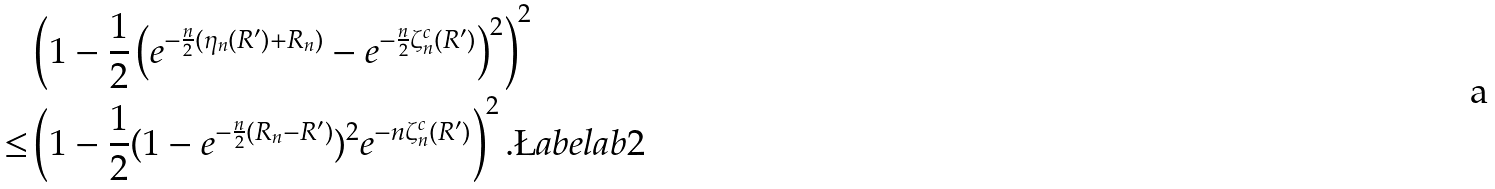Convert formula to latex. <formula><loc_0><loc_0><loc_500><loc_500>& \left ( 1 - \frac { 1 } { 2 } \left ( e ^ { - \frac { n } { 2 } ( \eta _ { n } ( R ^ { \prime } ) + R _ { n } ) } - e ^ { - \frac { n } { 2 } \zeta ^ { c } _ { n } ( R ^ { \prime } ) } \right ) ^ { 2 } \right ) ^ { 2 } \\ \leq & \left ( 1 - \frac { 1 } { 2 } ( 1 - e ^ { - \frac { n } { 2 } ( R _ { n } - R ^ { \prime } ) } ) ^ { 2 } e ^ { - n \zeta ^ { c } _ { n } ( R ^ { \prime } ) } \right ) ^ { 2 } . \L a b e l { a b 2 }</formula> 